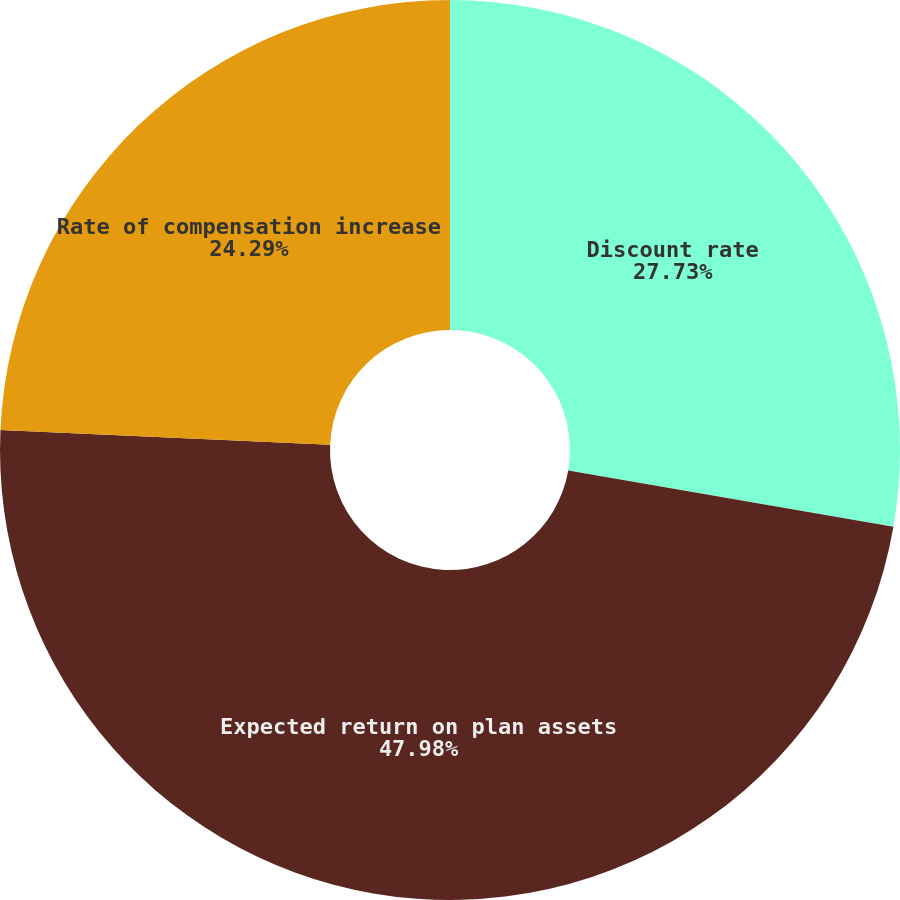Convert chart. <chart><loc_0><loc_0><loc_500><loc_500><pie_chart><fcel>Discount rate<fcel>Expected return on plan assets<fcel>Rate of compensation increase<nl><fcel>27.73%<fcel>47.98%<fcel>24.29%<nl></chart> 